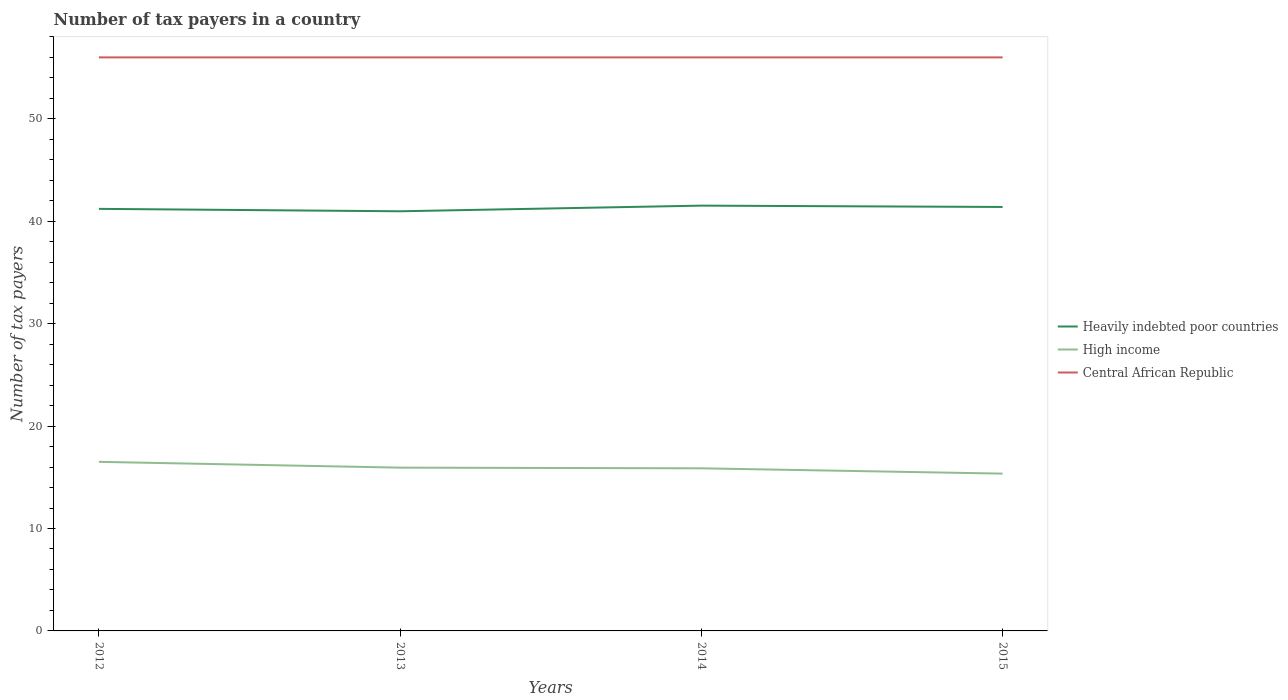How many different coloured lines are there?
Make the answer very short. 3. Is the number of lines equal to the number of legend labels?
Make the answer very short. Yes. Across all years, what is the maximum number of tax payers in in Heavily indebted poor countries?
Offer a terse response. 40.97. What is the total number of tax payers in in High income in the graph?
Keep it short and to the point. 0.07. What is the difference between the highest and the second highest number of tax payers in in High income?
Provide a short and direct response. 1.15. How many lines are there?
Offer a terse response. 3. How many years are there in the graph?
Your answer should be compact. 4. What is the difference between two consecutive major ticks on the Y-axis?
Offer a terse response. 10. Are the values on the major ticks of Y-axis written in scientific E-notation?
Ensure brevity in your answer.  No. Does the graph contain grids?
Provide a succinct answer. No. How many legend labels are there?
Offer a very short reply. 3. What is the title of the graph?
Offer a terse response. Number of tax payers in a country. Does "Greenland" appear as one of the legend labels in the graph?
Your response must be concise. No. What is the label or title of the Y-axis?
Make the answer very short. Number of tax payers. What is the Number of tax payers in Heavily indebted poor countries in 2012?
Offer a very short reply. 41.21. What is the Number of tax payers of High income in 2012?
Offer a very short reply. 16.51. What is the Number of tax payers in Central African Republic in 2012?
Provide a succinct answer. 56. What is the Number of tax payers of Heavily indebted poor countries in 2013?
Make the answer very short. 40.97. What is the Number of tax payers of High income in 2013?
Provide a short and direct response. 15.94. What is the Number of tax payers in Central African Republic in 2013?
Offer a very short reply. 56. What is the Number of tax payers of Heavily indebted poor countries in 2014?
Your answer should be compact. 41.53. What is the Number of tax payers of High income in 2014?
Your answer should be very brief. 15.88. What is the Number of tax payers in Heavily indebted poor countries in 2015?
Your answer should be very brief. 41.39. What is the Number of tax payers of High income in 2015?
Provide a succinct answer. 15.36. What is the Number of tax payers of Central African Republic in 2015?
Your answer should be very brief. 56. Across all years, what is the maximum Number of tax payers of Heavily indebted poor countries?
Make the answer very short. 41.53. Across all years, what is the maximum Number of tax payers of High income?
Your answer should be compact. 16.51. Across all years, what is the maximum Number of tax payers of Central African Republic?
Provide a short and direct response. 56. Across all years, what is the minimum Number of tax payers in Heavily indebted poor countries?
Ensure brevity in your answer.  40.97. Across all years, what is the minimum Number of tax payers in High income?
Your response must be concise. 15.36. What is the total Number of tax payers in Heavily indebted poor countries in the graph?
Offer a terse response. 165.11. What is the total Number of tax payers in High income in the graph?
Your answer should be very brief. 63.69. What is the total Number of tax payers of Central African Republic in the graph?
Provide a short and direct response. 224. What is the difference between the Number of tax payers of Heavily indebted poor countries in 2012 and that in 2013?
Provide a short and direct response. 0.24. What is the difference between the Number of tax payers in High income in 2012 and that in 2013?
Provide a short and direct response. 0.57. What is the difference between the Number of tax payers of Central African Republic in 2012 and that in 2013?
Provide a succinct answer. 0. What is the difference between the Number of tax payers in Heavily indebted poor countries in 2012 and that in 2014?
Offer a very short reply. -0.32. What is the difference between the Number of tax payers of High income in 2012 and that in 2014?
Your answer should be compact. 0.63. What is the difference between the Number of tax payers of Heavily indebted poor countries in 2012 and that in 2015?
Keep it short and to the point. -0.18. What is the difference between the Number of tax payers in High income in 2012 and that in 2015?
Your response must be concise. 1.15. What is the difference between the Number of tax payers in Heavily indebted poor countries in 2013 and that in 2014?
Your response must be concise. -0.55. What is the difference between the Number of tax payers in High income in 2013 and that in 2014?
Make the answer very short. 0.07. What is the difference between the Number of tax payers of Heavily indebted poor countries in 2013 and that in 2015?
Ensure brevity in your answer.  -0.42. What is the difference between the Number of tax payers of High income in 2013 and that in 2015?
Provide a short and direct response. 0.58. What is the difference between the Number of tax payers of Heavily indebted poor countries in 2014 and that in 2015?
Your response must be concise. 0.13. What is the difference between the Number of tax payers in High income in 2014 and that in 2015?
Provide a succinct answer. 0.52. What is the difference between the Number of tax payers of Heavily indebted poor countries in 2012 and the Number of tax payers of High income in 2013?
Keep it short and to the point. 25.27. What is the difference between the Number of tax payers in Heavily indebted poor countries in 2012 and the Number of tax payers in Central African Republic in 2013?
Ensure brevity in your answer.  -14.79. What is the difference between the Number of tax payers of High income in 2012 and the Number of tax payers of Central African Republic in 2013?
Ensure brevity in your answer.  -39.49. What is the difference between the Number of tax payers of Heavily indebted poor countries in 2012 and the Number of tax payers of High income in 2014?
Ensure brevity in your answer.  25.33. What is the difference between the Number of tax payers in Heavily indebted poor countries in 2012 and the Number of tax payers in Central African Republic in 2014?
Offer a terse response. -14.79. What is the difference between the Number of tax payers of High income in 2012 and the Number of tax payers of Central African Republic in 2014?
Provide a short and direct response. -39.49. What is the difference between the Number of tax payers in Heavily indebted poor countries in 2012 and the Number of tax payers in High income in 2015?
Provide a succinct answer. 25.85. What is the difference between the Number of tax payers of Heavily indebted poor countries in 2012 and the Number of tax payers of Central African Republic in 2015?
Keep it short and to the point. -14.79. What is the difference between the Number of tax payers of High income in 2012 and the Number of tax payers of Central African Republic in 2015?
Offer a very short reply. -39.49. What is the difference between the Number of tax payers in Heavily indebted poor countries in 2013 and the Number of tax payers in High income in 2014?
Keep it short and to the point. 25.1. What is the difference between the Number of tax payers in Heavily indebted poor countries in 2013 and the Number of tax payers in Central African Republic in 2014?
Give a very brief answer. -15.03. What is the difference between the Number of tax payers of High income in 2013 and the Number of tax payers of Central African Republic in 2014?
Make the answer very short. -40.06. What is the difference between the Number of tax payers of Heavily indebted poor countries in 2013 and the Number of tax payers of High income in 2015?
Offer a terse response. 25.61. What is the difference between the Number of tax payers in Heavily indebted poor countries in 2013 and the Number of tax payers in Central African Republic in 2015?
Your answer should be compact. -15.03. What is the difference between the Number of tax payers in High income in 2013 and the Number of tax payers in Central African Republic in 2015?
Ensure brevity in your answer.  -40.06. What is the difference between the Number of tax payers of Heavily indebted poor countries in 2014 and the Number of tax payers of High income in 2015?
Give a very brief answer. 26.17. What is the difference between the Number of tax payers in Heavily indebted poor countries in 2014 and the Number of tax payers in Central African Republic in 2015?
Give a very brief answer. -14.47. What is the difference between the Number of tax payers of High income in 2014 and the Number of tax payers of Central African Republic in 2015?
Your answer should be very brief. -40.12. What is the average Number of tax payers of Heavily indebted poor countries per year?
Your answer should be very brief. 41.28. What is the average Number of tax payers in High income per year?
Your answer should be compact. 15.92. What is the average Number of tax payers in Central African Republic per year?
Ensure brevity in your answer.  56. In the year 2012, what is the difference between the Number of tax payers in Heavily indebted poor countries and Number of tax payers in High income?
Make the answer very short. 24.7. In the year 2012, what is the difference between the Number of tax payers in Heavily indebted poor countries and Number of tax payers in Central African Republic?
Provide a succinct answer. -14.79. In the year 2012, what is the difference between the Number of tax payers of High income and Number of tax payers of Central African Republic?
Ensure brevity in your answer.  -39.49. In the year 2013, what is the difference between the Number of tax payers of Heavily indebted poor countries and Number of tax payers of High income?
Ensure brevity in your answer.  25.03. In the year 2013, what is the difference between the Number of tax payers in Heavily indebted poor countries and Number of tax payers in Central African Republic?
Your answer should be very brief. -15.03. In the year 2013, what is the difference between the Number of tax payers of High income and Number of tax payers of Central African Republic?
Give a very brief answer. -40.06. In the year 2014, what is the difference between the Number of tax payers in Heavily indebted poor countries and Number of tax payers in High income?
Offer a terse response. 25.65. In the year 2014, what is the difference between the Number of tax payers in Heavily indebted poor countries and Number of tax payers in Central African Republic?
Offer a terse response. -14.47. In the year 2014, what is the difference between the Number of tax payers of High income and Number of tax payers of Central African Republic?
Provide a succinct answer. -40.12. In the year 2015, what is the difference between the Number of tax payers of Heavily indebted poor countries and Number of tax payers of High income?
Make the answer very short. 26.03. In the year 2015, what is the difference between the Number of tax payers in Heavily indebted poor countries and Number of tax payers in Central African Republic?
Keep it short and to the point. -14.61. In the year 2015, what is the difference between the Number of tax payers of High income and Number of tax payers of Central African Republic?
Keep it short and to the point. -40.64. What is the ratio of the Number of tax payers of Heavily indebted poor countries in 2012 to that in 2013?
Offer a very short reply. 1.01. What is the ratio of the Number of tax payers of High income in 2012 to that in 2013?
Offer a terse response. 1.04. What is the ratio of the Number of tax payers in Central African Republic in 2012 to that in 2013?
Offer a very short reply. 1. What is the ratio of the Number of tax payers in Heavily indebted poor countries in 2012 to that in 2014?
Your answer should be compact. 0.99. What is the ratio of the Number of tax payers of High income in 2012 to that in 2014?
Offer a terse response. 1.04. What is the ratio of the Number of tax payers in Central African Republic in 2012 to that in 2014?
Provide a succinct answer. 1. What is the ratio of the Number of tax payers of Heavily indebted poor countries in 2012 to that in 2015?
Provide a short and direct response. 1. What is the ratio of the Number of tax payers of High income in 2012 to that in 2015?
Provide a short and direct response. 1.07. What is the ratio of the Number of tax payers of Central African Republic in 2012 to that in 2015?
Ensure brevity in your answer.  1. What is the ratio of the Number of tax payers in Heavily indebted poor countries in 2013 to that in 2014?
Make the answer very short. 0.99. What is the ratio of the Number of tax payers of Central African Republic in 2013 to that in 2014?
Offer a very short reply. 1. What is the ratio of the Number of tax payers in High income in 2013 to that in 2015?
Offer a very short reply. 1.04. What is the ratio of the Number of tax payers of Central African Republic in 2013 to that in 2015?
Provide a succinct answer. 1. What is the ratio of the Number of tax payers of High income in 2014 to that in 2015?
Make the answer very short. 1.03. What is the ratio of the Number of tax payers in Central African Republic in 2014 to that in 2015?
Your response must be concise. 1. What is the difference between the highest and the second highest Number of tax payers in Heavily indebted poor countries?
Ensure brevity in your answer.  0.13. What is the difference between the highest and the second highest Number of tax payers in High income?
Your response must be concise. 0.57. What is the difference between the highest and the lowest Number of tax payers of Heavily indebted poor countries?
Offer a terse response. 0.55. What is the difference between the highest and the lowest Number of tax payers in High income?
Ensure brevity in your answer.  1.15. What is the difference between the highest and the lowest Number of tax payers in Central African Republic?
Offer a very short reply. 0. 